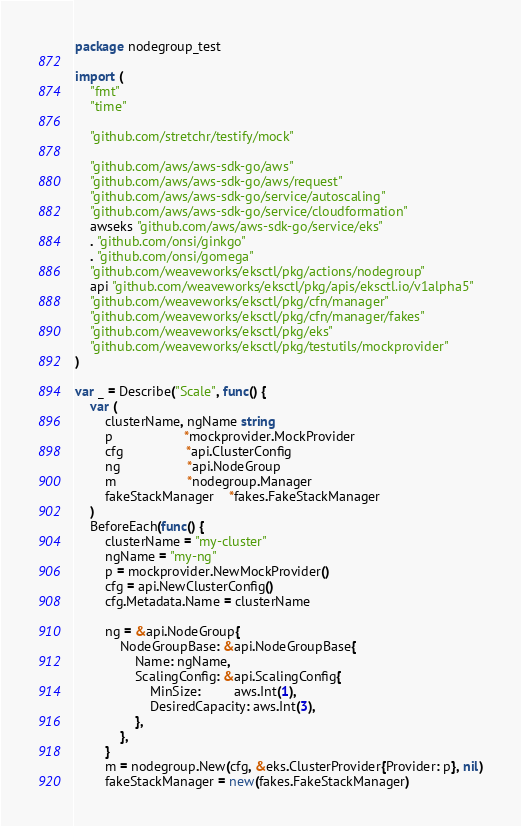<code> <loc_0><loc_0><loc_500><loc_500><_Go_>package nodegroup_test

import (
	"fmt"
	"time"

	"github.com/stretchr/testify/mock"

	"github.com/aws/aws-sdk-go/aws"
	"github.com/aws/aws-sdk-go/aws/request"
	"github.com/aws/aws-sdk-go/service/autoscaling"
	"github.com/aws/aws-sdk-go/service/cloudformation"
	awseks "github.com/aws/aws-sdk-go/service/eks"
	. "github.com/onsi/ginkgo"
	. "github.com/onsi/gomega"
	"github.com/weaveworks/eksctl/pkg/actions/nodegroup"
	api "github.com/weaveworks/eksctl/pkg/apis/eksctl.io/v1alpha5"
	"github.com/weaveworks/eksctl/pkg/cfn/manager"
	"github.com/weaveworks/eksctl/pkg/cfn/manager/fakes"
	"github.com/weaveworks/eksctl/pkg/eks"
	"github.com/weaveworks/eksctl/pkg/testutils/mockprovider"
)

var _ = Describe("Scale", func() {
	var (
		clusterName, ngName string
		p                   *mockprovider.MockProvider
		cfg                 *api.ClusterConfig
		ng                  *api.NodeGroup
		m                   *nodegroup.Manager
		fakeStackManager    *fakes.FakeStackManager
	)
	BeforeEach(func() {
		clusterName = "my-cluster"
		ngName = "my-ng"
		p = mockprovider.NewMockProvider()
		cfg = api.NewClusterConfig()
		cfg.Metadata.Name = clusterName

		ng = &api.NodeGroup{
			NodeGroupBase: &api.NodeGroupBase{
				Name: ngName,
				ScalingConfig: &api.ScalingConfig{
					MinSize:         aws.Int(1),
					DesiredCapacity: aws.Int(3),
				},
			},
		}
		m = nodegroup.New(cfg, &eks.ClusterProvider{Provider: p}, nil)
		fakeStackManager = new(fakes.FakeStackManager)</code> 